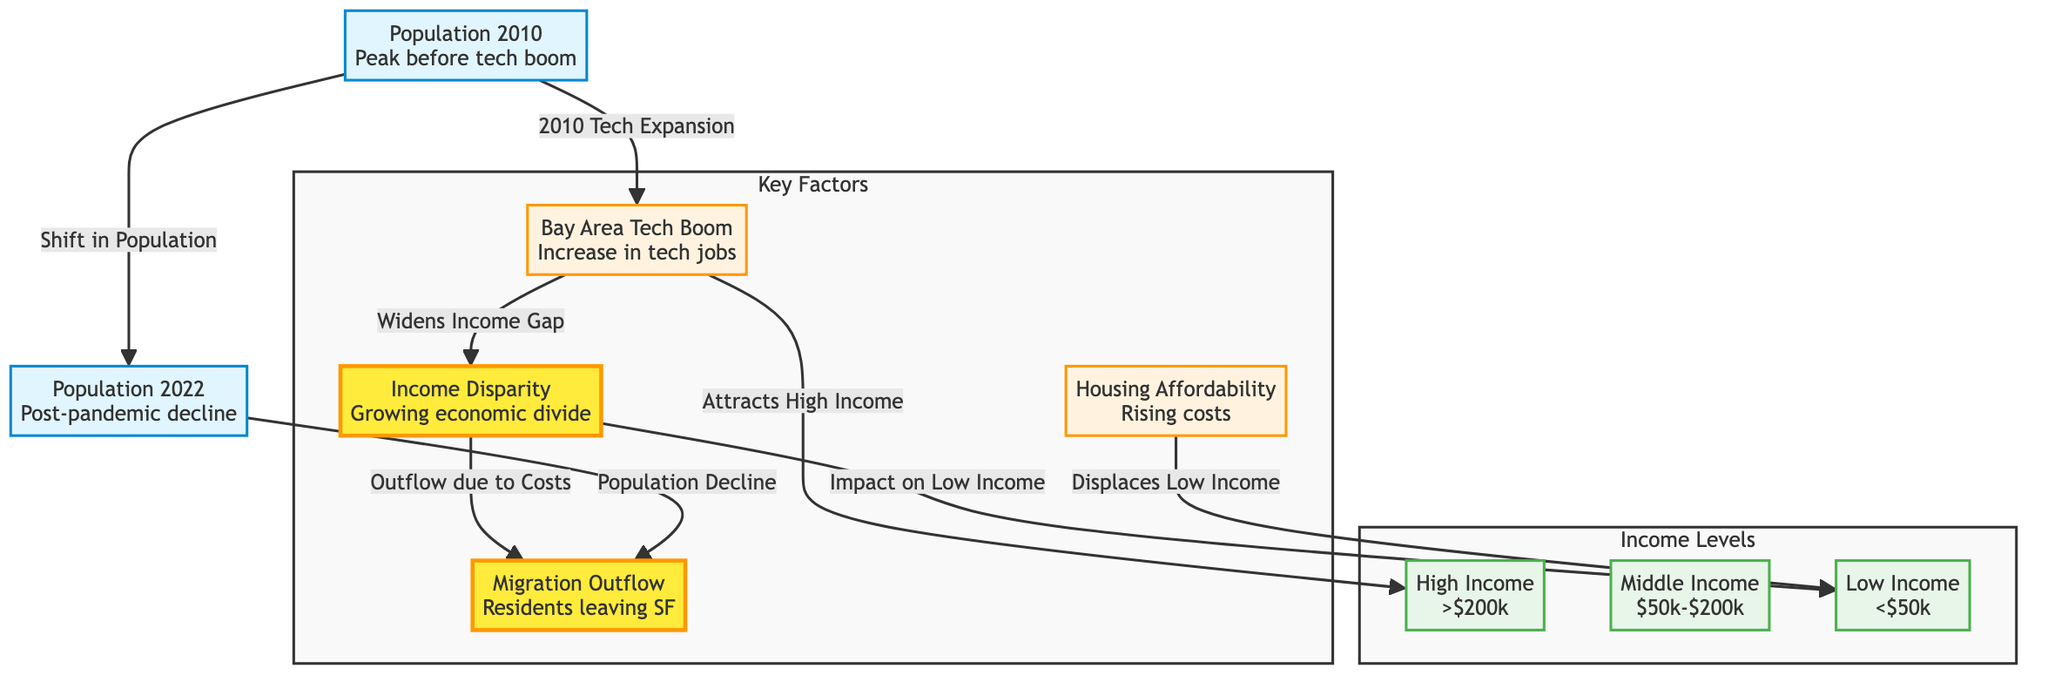What's the population trend from 2010 to 2022? The diagram shows a transition from a peak population in 2010 to a decline in population in 2022, indicating that the overall population fell in the later year.
Answer: Decline How many income levels are represented in the diagram? The diagram categorizes residents into three distinct income levels: high income, middle income, and low income.
Answer: Three What factor is primarily associated with attracting high-income residents? The diagram indicates that the "Bay Area Tech Boom" is the main factor responsible for attracting high-income residents to San Francisco.
Answer: Bay Area Tech Boom What impact does housing affordability have on low-income residents? According to the diagram, "Housing Affordability" directly contributes to the displacement of low-income residents from San Francisco.
Answer: Displacement How does migration outflow relate to housing costs? The diagram illustrates that "Outflow due to Costs" connects to "Housing Affordability" and also results in a population decline, showing that residents are leaving San Francisco primarily because of high costs.
Answer: Residents leaving Which income level is most affected by the growing economic divide? The diagram suggests that the low-income group is most impacted by the "Income Disparity," as they are caught between rising costs and diminishing resources.
Answer: Low Income What is the outcome of the tech expansion in 2010? The tech expansion in 2010 not only attracted high-income residents, but it also contributed to widening the income gap within San Francisco, leading to economic disparity.
Answer: Widened Income Gap What connects the population decline in 2022 to migration? The "Population Decline" node leads to "Migration Outflow," indicating that the decrease in the population is related to residents leaving the city for various reasons.
Answer: Migration Outflow Which factor is linked to both housing affordability and income level impacts? "Disparity" connects "Housing Affordability" to the impact on "Low Income," showing that the lack of affordable housing plays a significant role in the economic divide faced by low-income residents.
Answer: Disparity 